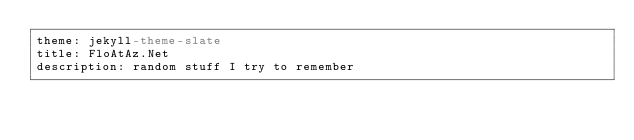<code> <loc_0><loc_0><loc_500><loc_500><_YAML_>theme: jekyll-theme-slate
title: FloAtAz.Net
description: random stuff I try to remember
</code> 